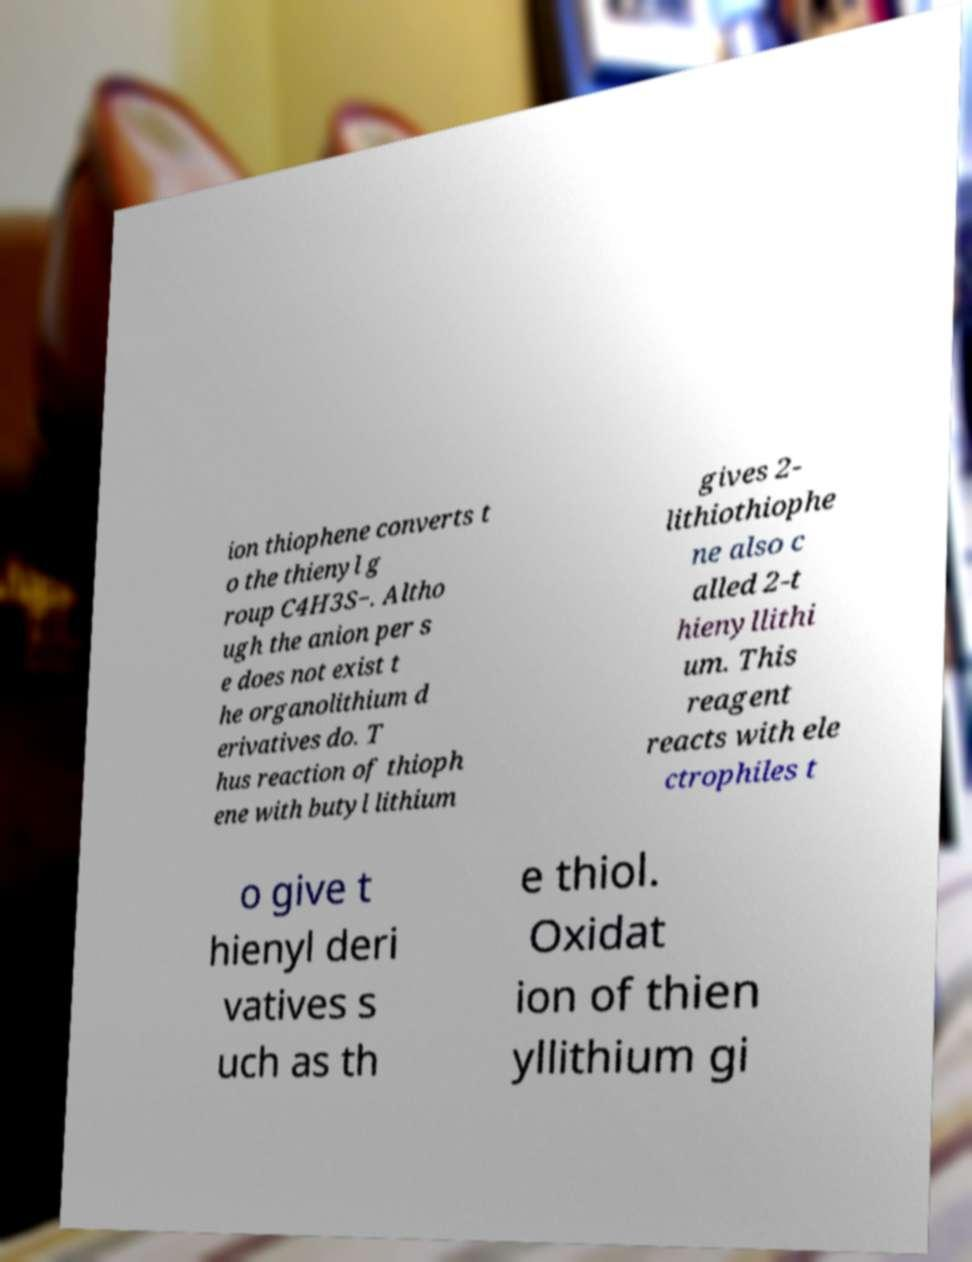Please read and relay the text visible in this image. What does it say? ion thiophene converts t o the thienyl g roup C4H3S−. Altho ugh the anion per s e does not exist t he organolithium d erivatives do. T hus reaction of thioph ene with butyl lithium gives 2- lithiothiophe ne also c alled 2-t hienyllithi um. This reagent reacts with ele ctrophiles t o give t hienyl deri vatives s uch as th e thiol. Oxidat ion of thien yllithium gi 